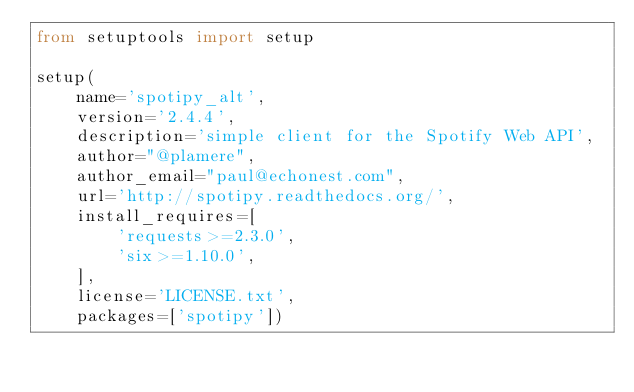Convert code to text. <code><loc_0><loc_0><loc_500><loc_500><_Python_>from setuptools import setup

setup(
    name='spotipy_alt',
    version='2.4.4',
    description='simple client for the Spotify Web API',
    author="@plamere",
    author_email="paul@echonest.com",
    url='http://spotipy.readthedocs.org/',
    install_requires=[
        'requests>=2.3.0',
        'six>=1.10.0',
    ],
    license='LICENSE.txt',
    packages=['spotipy'])
</code> 